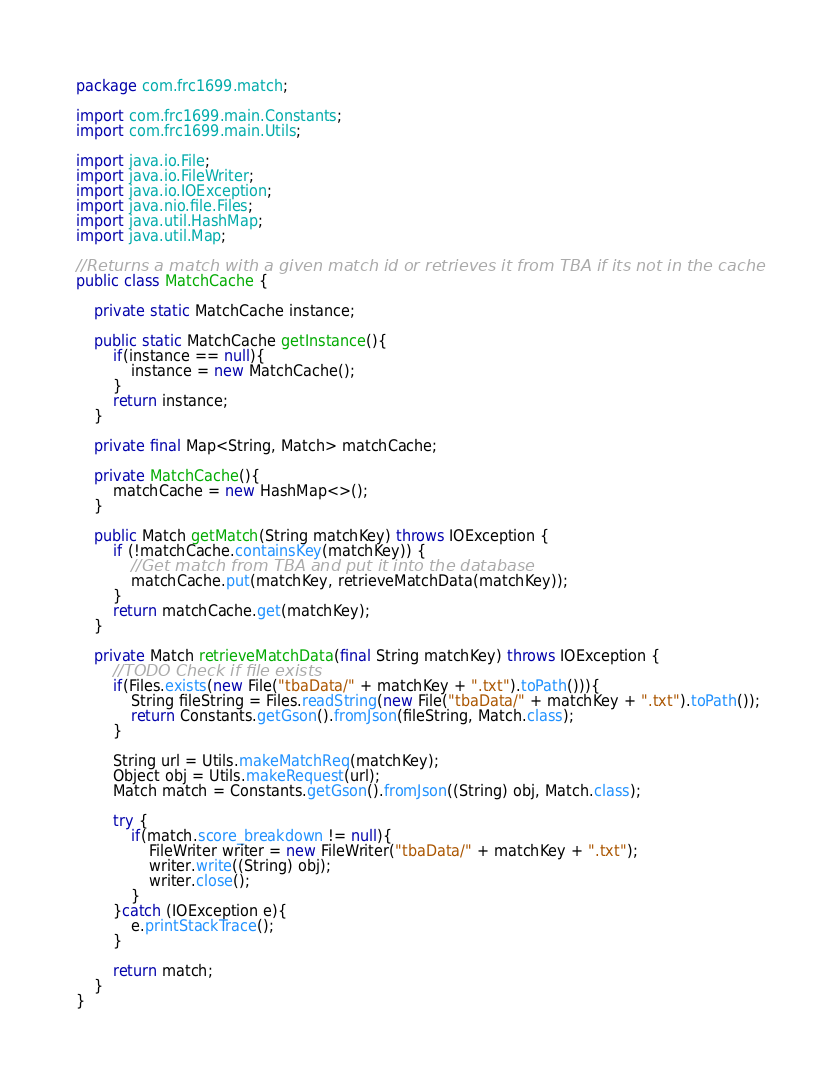Convert code to text. <code><loc_0><loc_0><loc_500><loc_500><_Java_>package com.frc1699.match;

import com.frc1699.main.Constants;
import com.frc1699.main.Utils;

import java.io.File;
import java.io.FileWriter;
import java.io.IOException;
import java.nio.file.Files;
import java.util.HashMap;
import java.util.Map;

//Returns a match with a given match id or retrieves it from TBA if its not in the cache
public class MatchCache {

    private static MatchCache instance;

    public static MatchCache getInstance(){
        if(instance == null){
            instance = new MatchCache();
        }
        return instance;
    }

    private final Map<String, Match> matchCache;

    private MatchCache(){
        matchCache = new HashMap<>();
    }

    public Match getMatch(String matchKey) throws IOException {
        if (!matchCache.containsKey(matchKey)) {
            //Get match from TBA and put it into the database
            matchCache.put(matchKey, retrieveMatchData(matchKey));
        }
        return matchCache.get(matchKey);
    }

    private Match retrieveMatchData(final String matchKey) throws IOException {
        //TODO Check if file exists
        if(Files.exists(new File("tbaData/" + matchKey + ".txt").toPath())){
            String fileString = Files.readString(new File("tbaData/" + matchKey + ".txt").toPath());
            return Constants.getGson().fromJson(fileString, Match.class);
        }

        String url = Utils.makeMatchReq(matchKey);
        Object obj = Utils.makeRequest(url);
        Match match = Constants.getGson().fromJson((String) obj, Match.class);

        try {
            if(match.score_breakdown != null){
                FileWriter writer = new FileWriter("tbaData/" + matchKey + ".txt");
                writer.write((String) obj);
                writer.close();
            }
        }catch (IOException e){
            e.printStackTrace();
        }

        return match;
    }
}
</code> 